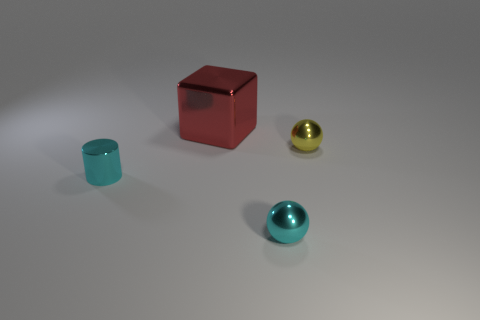Add 3 tiny cyan shiny things. How many objects exist? 7 Subtract all cubes. How many objects are left? 3 Subtract all yellow spheres. Subtract all small cyan metal cylinders. How many objects are left? 2 Add 1 tiny cyan cylinders. How many tiny cyan cylinders are left? 2 Add 3 cyan balls. How many cyan balls exist? 4 Subtract 1 cyan spheres. How many objects are left? 3 